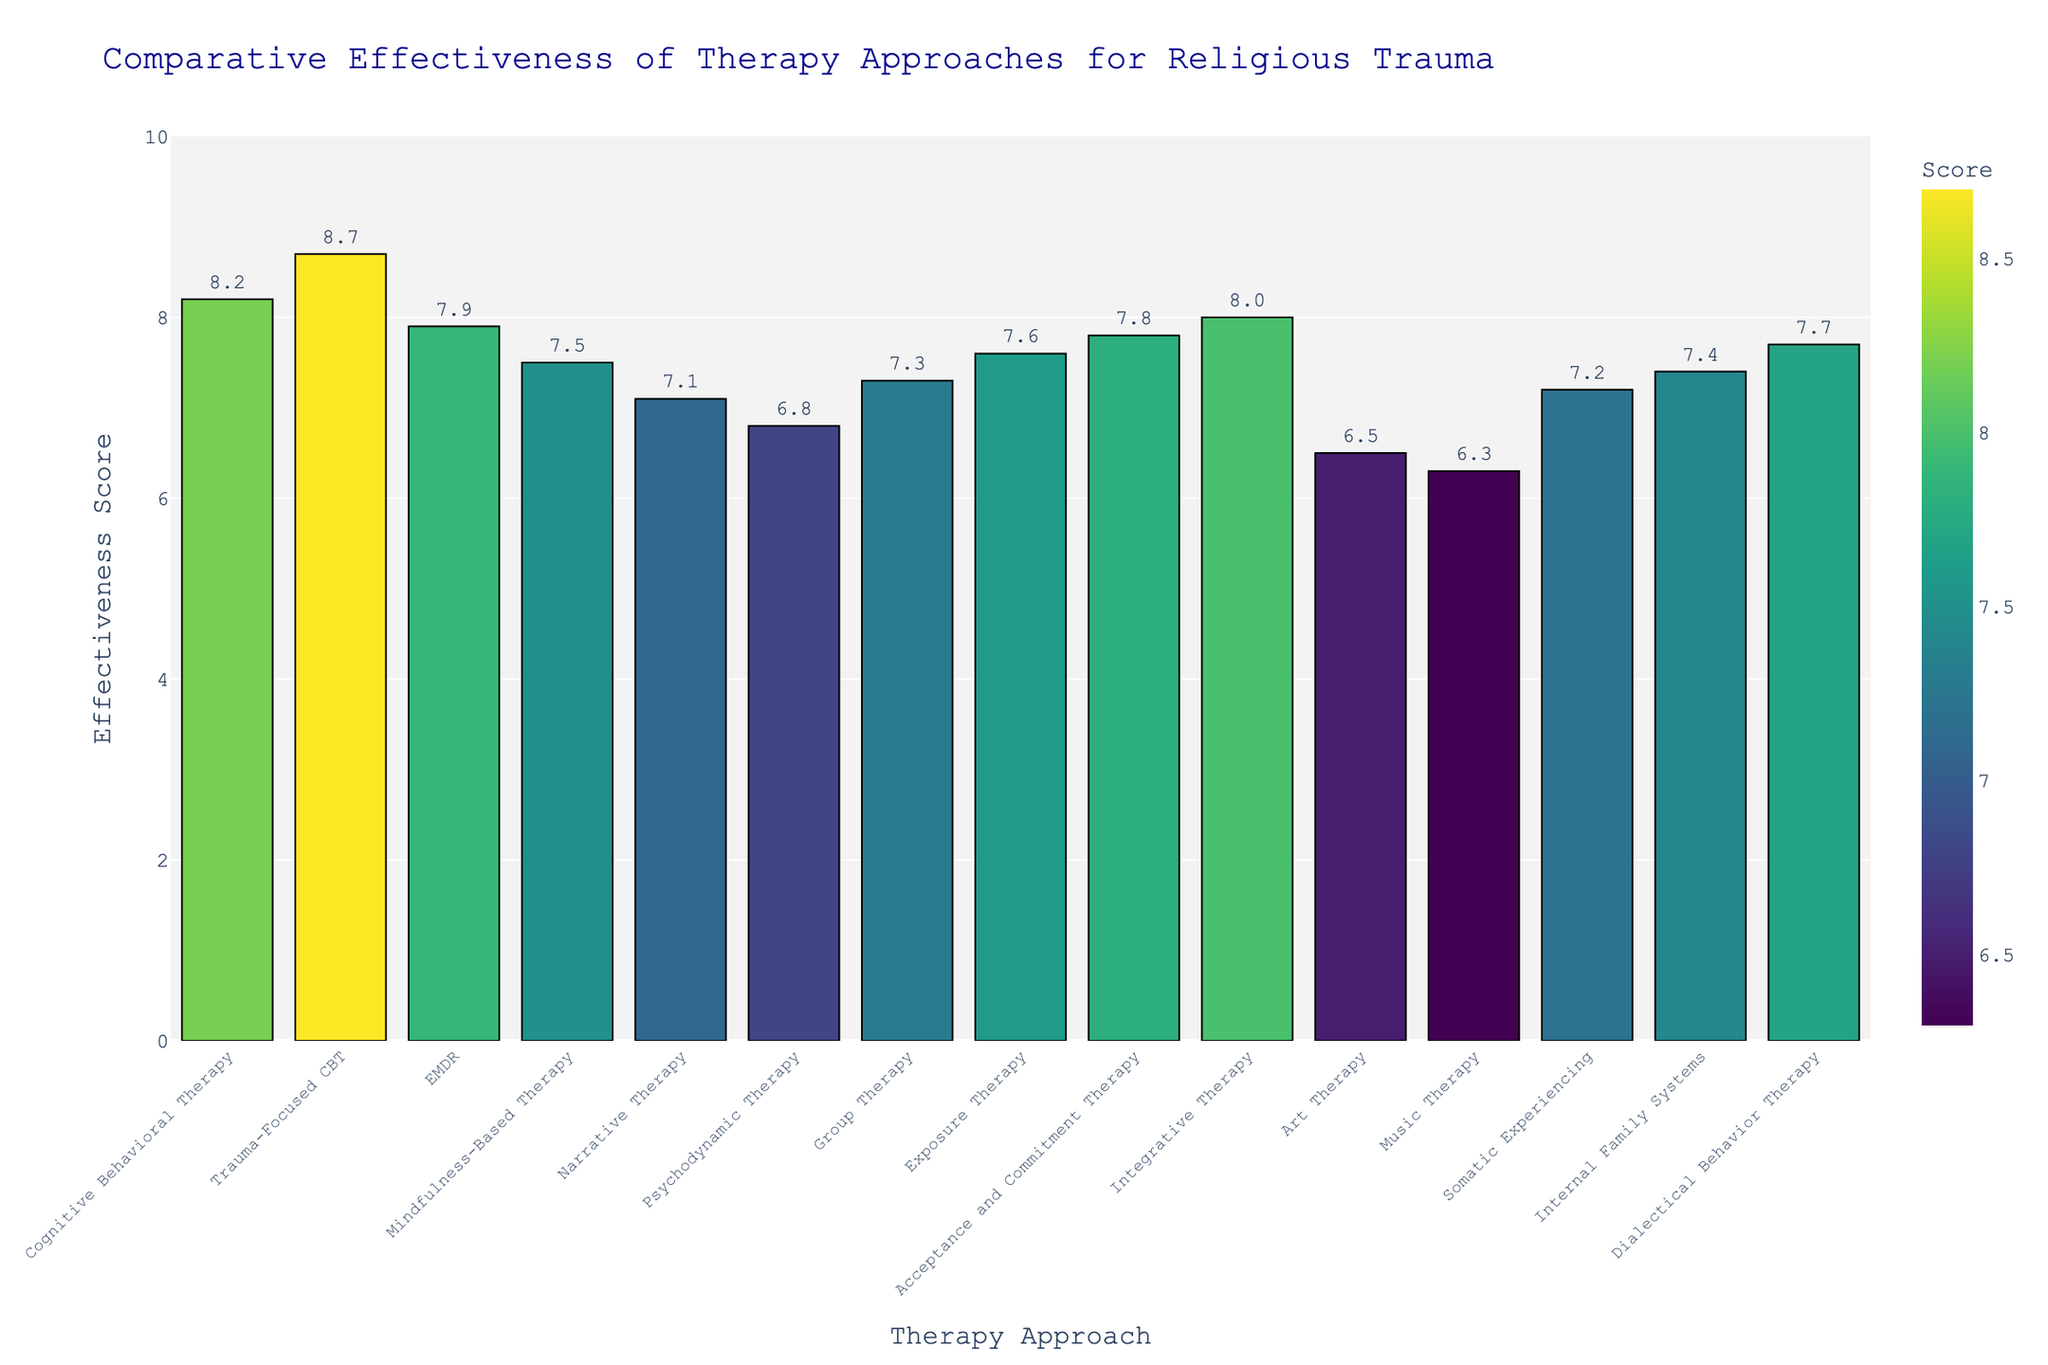What therapy approach has the highest effectiveness score? The bar chart shows the effectiveness scores for different therapy approaches. The highest bar represents the therapy with the highest score.
Answer: Trauma-Focused CBT Which therapy approach has a higher effectiveness score: EMDR or Acceptance and Commitment Therapy? Look at the bars for EMDR and Acceptance and Commitment Therapy on the chart and compare their heights and values.
Answer: Acceptance and Commitment Therapy What is the numerical difference between the effectiveness scores of Cognitive Behavioral Therapy and Psychodynamic Therapy? Find the effectiveness scores for Cognitive Behavioral Therapy (8.2) and Psychodynamic Therapy (6.8) from the chart and subtract the smaller from the larger: 8.2 - 6.8.
Answer: 1.4 What is the average effectiveness score of Cognitive Behavioral Therapy, Trauma-Focused CBT, and Integrative Therapy? Sum the effectiveness scores of the three therapies (8.2 + 8.7 + 8.0) and divide by the number of therapies (3): (8.2 + 8.7 + 8.0) / 3.
Answer: 8.3 Which therapy approach has the darkest color on the chart? The darkest color represents the highest effectiveness score on a Viridis color scale. Identify the bar with the darkest color, indicating the highest score.
Answer: Trauma-Focused CBT Is Group Therapy more effective than Mindfulness-Based Therapy? Compare the heights and effectiveness scores of the bars for Group Therapy and Mindfulness-Based Therapy.
Answer: Yes How many therapy approaches have an effectiveness score of 7.5 and above? Count the number of bars on the chart with effectiveness scores greater than or equal to 7.5.
Answer: 9 What's the effectiveness score range depicted in the chart? Identify the minimum and maximum effectiveness scores among the therapy approaches. The range will be from the lowest score value to the highest score value.
Answer: 6.3 to 8.7 